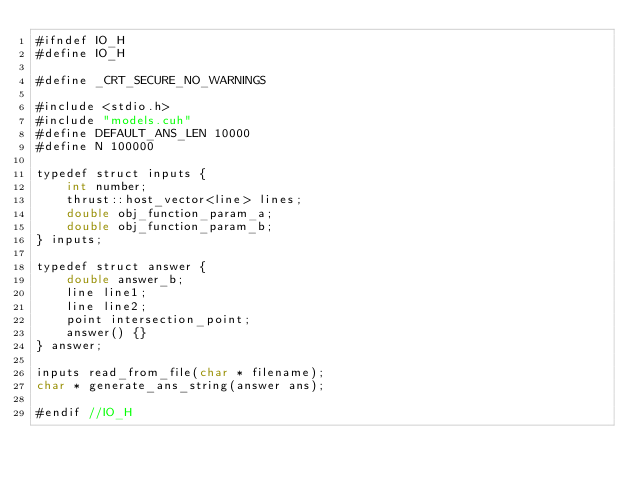Convert code to text. <code><loc_0><loc_0><loc_500><loc_500><_Cuda_>#ifndef IO_H
#define IO_H

#define _CRT_SECURE_NO_WARNINGS

#include <stdio.h>
#include "models.cuh"
#define DEFAULT_ANS_LEN 10000
#define N 100000

typedef struct inputs {
    int number;
    thrust::host_vector<line> lines;
    double obj_function_param_a;
    double obj_function_param_b;
} inputs;

typedef struct answer {
    double answer_b;
    line line1;
    line line2;
    point intersection_point;
	answer() {}
} answer;

inputs read_from_file(char * filename);
char * generate_ans_string(answer ans);

#endif //IO_H
</code> 